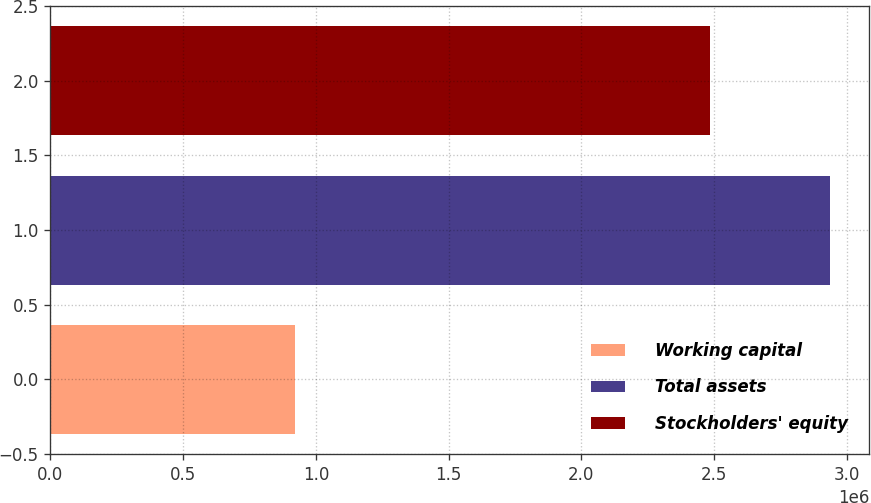Convert chart. <chart><loc_0><loc_0><loc_500><loc_500><bar_chart><fcel>Working capital<fcel>Total assets<fcel>Stockholders' equity<nl><fcel>920422<fcel>2.93747e+06<fcel>2.48306e+06<nl></chart> 